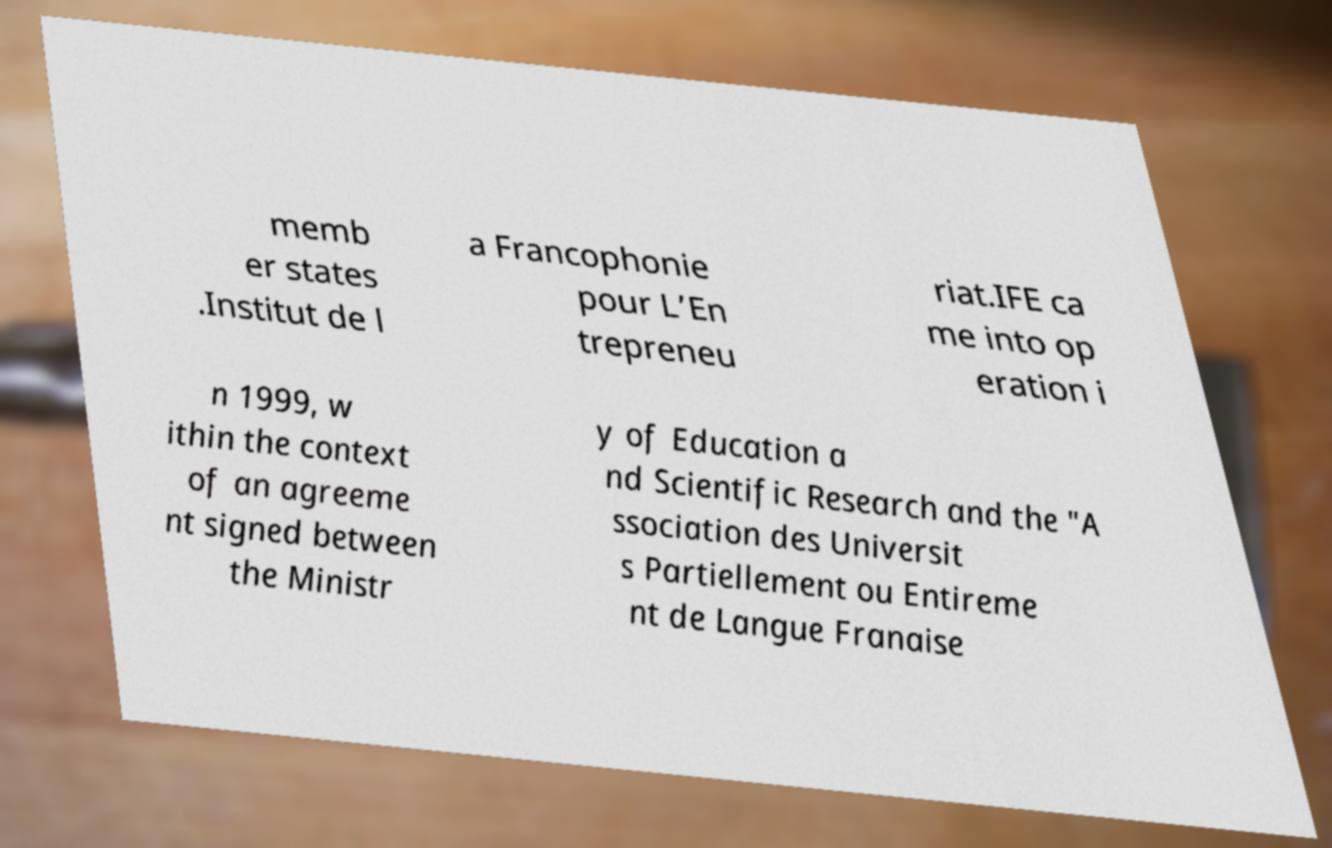Could you assist in decoding the text presented in this image and type it out clearly? memb er states .Institut de l a Francophonie pour L’En trepreneu riat.IFE ca me into op eration i n 1999, w ithin the context of an agreeme nt signed between the Ministr y of Education a nd Scientific Research and the "A ssociation des Universit s Partiellement ou Entireme nt de Langue Franaise 